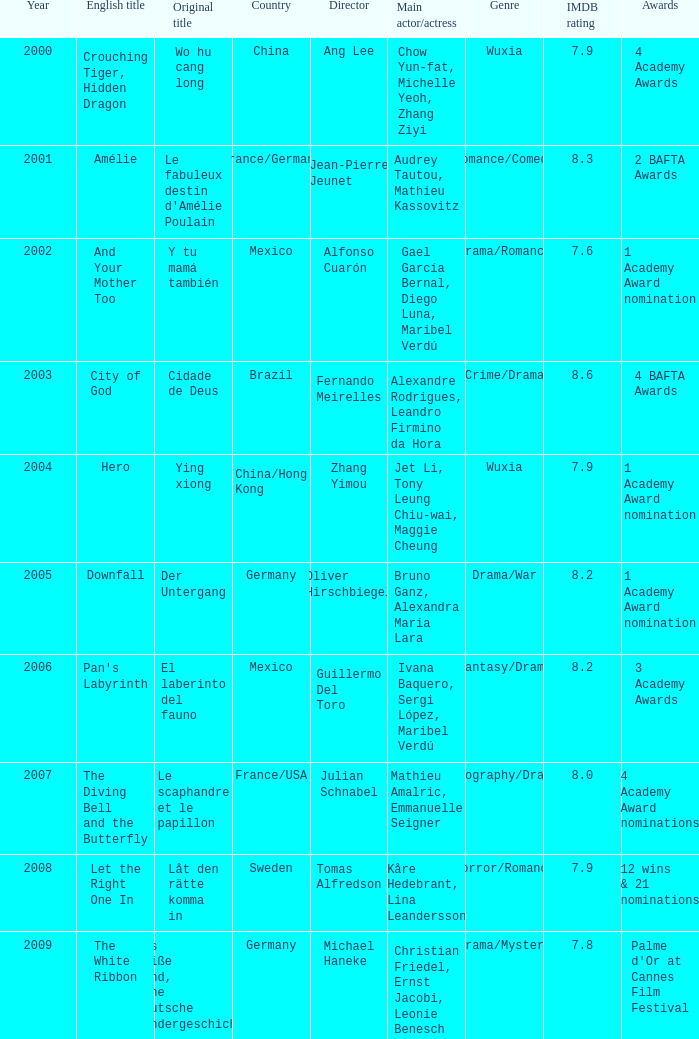Tell me the country for julian schnabel France/USA. 